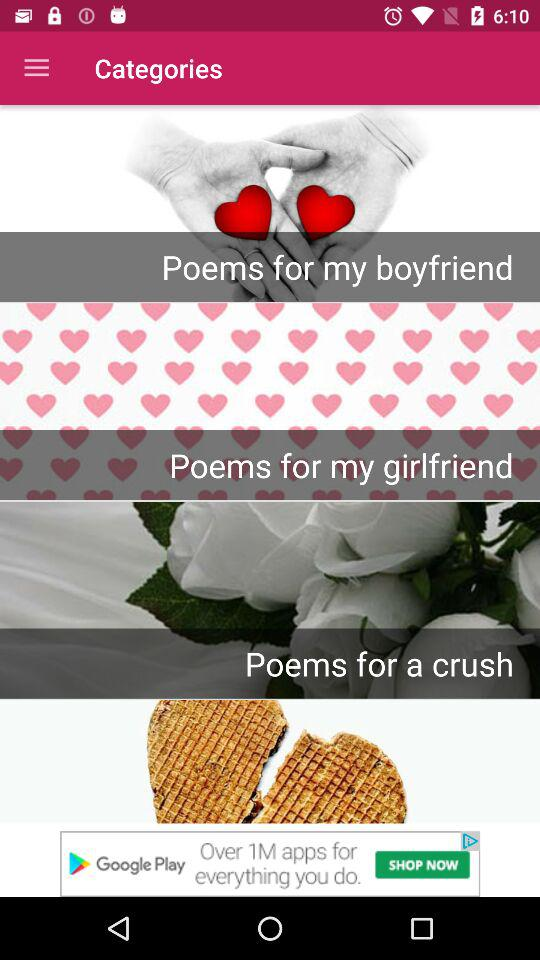How many categories of poems are there?
When the provided information is insufficient, respond with <no answer>. <no answer> 